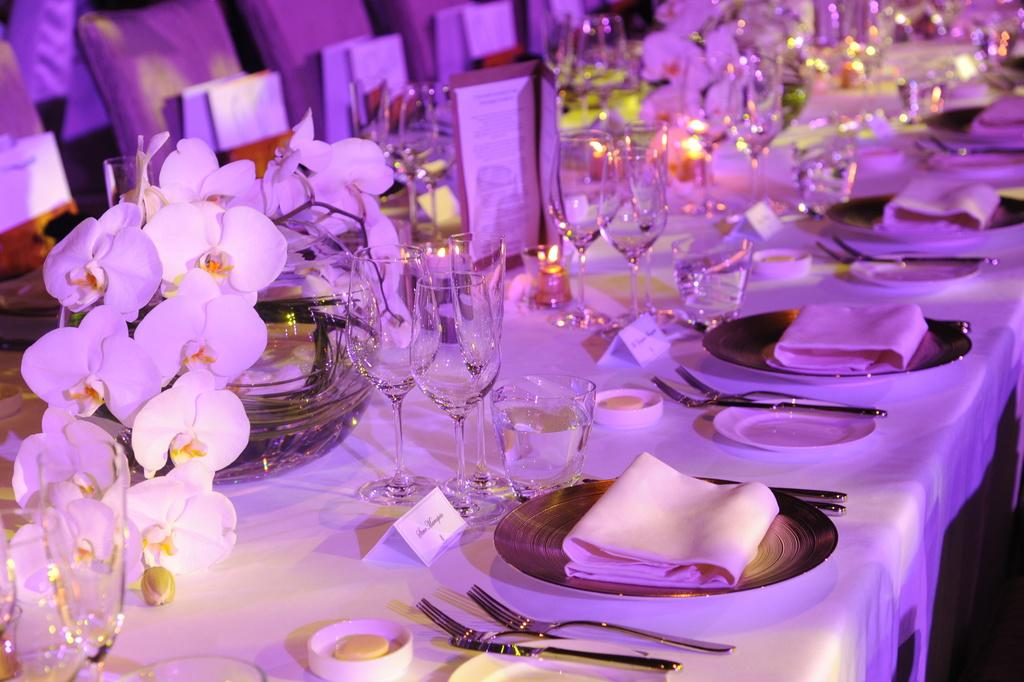What type of furniture is in the room? There is a big chair and multiple chairs on a table in the room. What items are used for drinking in the room? Wine glasses are present in the room. What items are used for cleaning or wiping in the room? Tissue papers are present in the room. What items are used for eating in the room? Plates, spoons, and wine glasses are present in the room. What decorative items are present in the room? Flowers are present in the room. What is the number of requests made in the room? There is no information about requests being made in the room, so it cannot be determined from the image. 